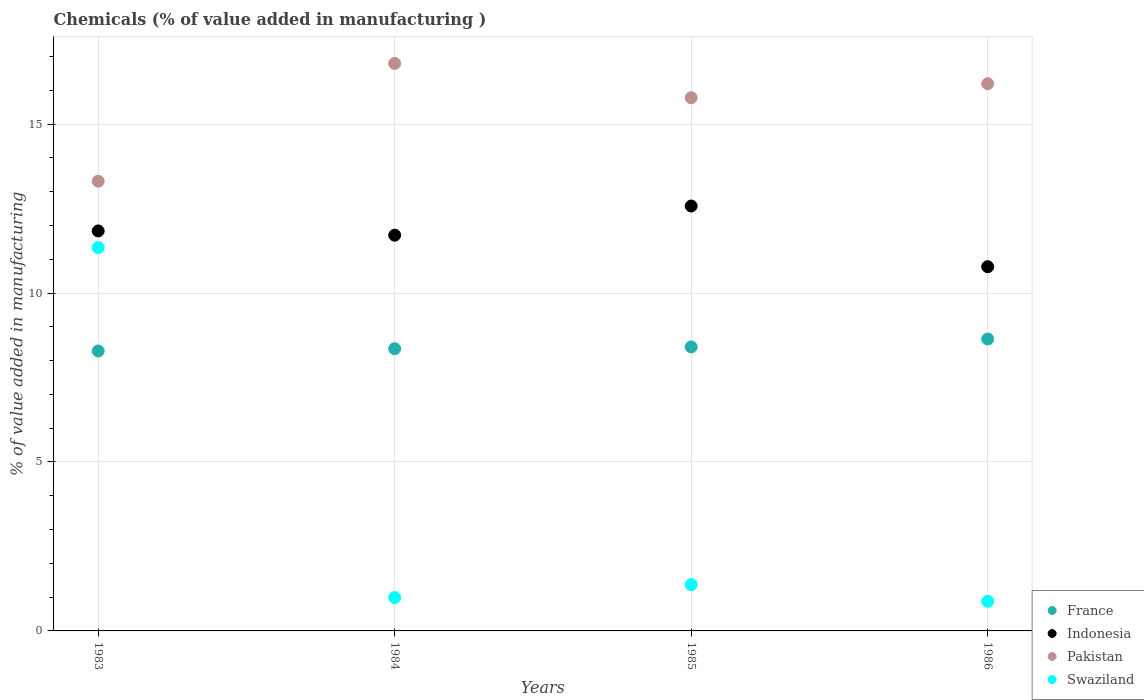How many different coloured dotlines are there?
Your answer should be very brief. 4. Is the number of dotlines equal to the number of legend labels?
Make the answer very short. Yes. What is the value added in manufacturing chemicals in Pakistan in 1984?
Your answer should be compact. 16.79. Across all years, what is the maximum value added in manufacturing chemicals in Swaziland?
Your answer should be compact. 11.35. Across all years, what is the minimum value added in manufacturing chemicals in Pakistan?
Offer a very short reply. 13.31. In which year was the value added in manufacturing chemicals in Pakistan minimum?
Give a very brief answer. 1983. What is the total value added in manufacturing chemicals in France in the graph?
Ensure brevity in your answer.  33.68. What is the difference between the value added in manufacturing chemicals in Indonesia in 1983 and that in 1985?
Your answer should be compact. -0.74. What is the difference between the value added in manufacturing chemicals in Pakistan in 1983 and the value added in manufacturing chemicals in France in 1986?
Offer a terse response. 4.67. What is the average value added in manufacturing chemicals in Swaziland per year?
Your response must be concise. 3.64. In the year 1983, what is the difference between the value added in manufacturing chemicals in Pakistan and value added in manufacturing chemicals in Indonesia?
Your answer should be compact. 1.47. In how many years, is the value added in manufacturing chemicals in Swaziland greater than 13 %?
Give a very brief answer. 0. What is the ratio of the value added in manufacturing chemicals in France in 1984 to that in 1986?
Provide a succinct answer. 0.97. Is the difference between the value added in manufacturing chemicals in Pakistan in 1983 and 1986 greater than the difference between the value added in manufacturing chemicals in Indonesia in 1983 and 1986?
Your answer should be very brief. No. What is the difference between the highest and the second highest value added in manufacturing chemicals in Indonesia?
Keep it short and to the point. 0.74. What is the difference between the highest and the lowest value added in manufacturing chemicals in Swaziland?
Make the answer very short. 10.47. In how many years, is the value added in manufacturing chemicals in Swaziland greater than the average value added in manufacturing chemicals in Swaziland taken over all years?
Ensure brevity in your answer.  1. Is the sum of the value added in manufacturing chemicals in France in 1983 and 1985 greater than the maximum value added in manufacturing chemicals in Swaziland across all years?
Give a very brief answer. Yes. How many years are there in the graph?
Provide a succinct answer. 4. What is the difference between two consecutive major ticks on the Y-axis?
Offer a very short reply. 5. Does the graph contain any zero values?
Your answer should be compact. No. Does the graph contain grids?
Provide a short and direct response. Yes. What is the title of the graph?
Provide a short and direct response. Chemicals (% of value added in manufacturing ). What is the label or title of the Y-axis?
Offer a very short reply. % of value added in manufacturing. What is the % of value added in manufacturing of France in 1983?
Your answer should be very brief. 8.28. What is the % of value added in manufacturing of Indonesia in 1983?
Offer a very short reply. 11.84. What is the % of value added in manufacturing of Pakistan in 1983?
Keep it short and to the point. 13.31. What is the % of value added in manufacturing in Swaziland in 1983?
Give a very brief answer. 11.35. What is the % of value added in manufacturing in France in 1984?
Provide a short and direct response. 8.35. What is the % of value added in manufacturing in Indonesia in 1984?
Give a very brief answer. 11.71. What is the % of value added in manufacturing of Pakistan in 1984?
Keep it short and to the point. 16.79. What is the % of value added in manufacturing in Swaziland in 1984?
Make the answer very short. 0.99. What is the % of value added in manufacturing in France in 1985?
Make the answer very short. 8.41. What is the % of value added in manufacturing in Indonesia in 1985?
Offer a terse response. 12.58. What is the % of value added in manufacturing in Pakistan in 1985?
Offer a very short reply. 15.78. What is the % of value added in manufacturing of Swaziland in 1985?
Your answer should be compact. 1.37. What is the % of value added in manufacturing in France in 1986?
Give a very brief answer. 8.64. What is the % of value added in manufacturing of Indonesia in 1986?
Offer a terse response. 10.78. What is the % of value added in manufacturing in Pakistan in 1986?
Your answer should be very brief. 16.2. What is the % of value added in manufacturing of Swaziland in 1986?
Keep it short and to the point. 0.88. Across all years, what is the maximum % of value added in manufacturing in France?
Offer a very short reply. 8.64. Across all years, what is the maximum % of value added in manufacturing of Indonesia?
Your answer should be very brief. 12.58. Across all years, what is the maximum % of value added in manufacturing of Pakistan?
Give a very brief answer. 16.79. Across all years, what is the maximum % of value added in manufacturing of Swaziland?
Keep it short and to the point. 11.35. Across all years, what is the minimum % of value added in manufacturing of France?
Ensure brevity in your answer.  8.28. Across all years, what is the minimum % of value added in manufacturing of Indonesia?
Provide a short and direct response. 10.78. Across all years, what is the minimum % of value added in manufacturing in Pakistan?
Your answer should be compact. 13.31. Across all years, what is the minimum % of value added in manufacturing of Swaziland?
Ensure brevity in your answer.  0.88. What is the total % of value added in manufacturing in France in the graph?
Provide a succinct answer. 33.68. What is the total % of value added in manufacturing in Indonesia in the graph?
Your response must be concise. 46.9. What is the total % of value added in manufacturing in Pakistan in the graph?
Make the answer very short. 62.08. What is the total % of value added in manufacturing in Swaziland in the graph?
Provide a succinct answer. 14.58. What is the difference between the % of value added in manufacturing in France in 1983 and that in 1984?
Ensure brevity in your answer.  -0.07. What is the difference between the % of value added in manufacturing of Indonesia in 1983 and that in 1984?
Give a very brief answer. 0.13. What is the difference between the % of value added in manufacturing in Pakistan in 1983 and that in 1984?
Your response must be concise. -3.48. What is the difference between the % of value added in manufacturing of Swaziland in 1983 and that in 1984?
Keep it short and to the point. 10.36. What is the difference between the % of value added in manufacturing of France in 1983 and that in 1985?
Your response must be concise. -0.12. What is the difference between the % of value added in manufacturing in Indonesia in 1983 and that in 1985?
Provide a succinct answer. -0.74. What is the difference between the % of value added in manufacturing of Pakistan in 1983 and that in 1985?
Your response must be concise. -2.47. What is the difference between the % of value added in manufacturing of Swaziland in 1983 and that in 1985?
Keep it short and to the point. 9.98. What is the difference between the % of value added in manufacturing of France in 1983 and that in 1986?
Keep it short and to the point. -0.35. What is the difference between the % of value added in manufacturing of Indonesia in 1983 and that in 1986?
Make the answer very short. 1.06. What is the difference between the % of value added in manufacturing in Pakistan in 1983 and that in 1986?
Provide a short and direct response. -2.88. What is the difference between the % of value added in manufacturing of Swaziland in 1983 and that in 1986?
Ensure brevity in your answer.  10.47. What is the difference between the % of value added in manufacturing of France in 1984 and that in 1985?
Provide a succinct answer. -0.05. What is the difference between the % of value added in manufacturing of Indonesia in 1984 and that in 1985?
Your response must be concise. -0.86. What is the difference between the % of value added in manufacturing in Pakistan in 1984 and that in 1985?
Provide a succinct answer. 1.01. What is the difference between the % of value added in manufacturing in Swaziland in 1984 and that in 1985?
Give a very brief answer. -0.38. What is the difference between the % of value added in manufacturing of France in 1984 and that in 1986?
Offer a very short reply. -0.29. What is the difference between the % of value added in manufacturing of Indonesia in 1984 and that in 1986?
Your response must be concise. 0.93. What is the difference between the % of value added in manufacturing of Pakistan in 1984 and that in 1986?
Ensure brevity in your answer.  0.6. What is the difference between the % of value added in manufacturing of Swaziland in 1984 and that in 1986?
Ensure brevity in your answer.  0.11. What is the difference between the % of value added in manufacturing of France in 1985 and that in 1986?
Provide a succinct answer. -0.23. What is the difference between the % of value added in manufacturing of Indonesia in 1985 and that in 1986?
Make the answer very short. 1.8. What is the difference between the % of value added in manufacturing of Pakistan in 1985 and that in 1986?
Ensure brevity in your answer.  -0.41. What is the difference between the % of value added in manufacturing in Swaziland in 1985 and that in 1986?
Your answer should be very brief. 0.49. What is the difference between the % of value added in manufacturing in France in 1983 and the % of value added in manufacturing in Indonesia in 1984?
Keep it short and to the point. -3.43. What is the difference between the % of value added in manufacturing in France in 1983 and the % of value added in manufacturing in Pakistan in 1984?
Keep it short and to the point. -8.51. What is the difference between the % of value added in manufacturing of France in 1983 and the % of value added in manufacturing of Swaziland in 1984?
Offer a very short reply. 7.3. What is the difference between the % of value added in manufacturing in Indonesia in 1983 and the % of value added in manufacturing in Pakistan in 1984?
Ensure brevity in your answer.  -4.96. What is the difference between the % of value added in manufacturing of Indonesia in 1983 and the % of value added in manufacturing of Swaziland in 1984?
Provide a succinct answer. 10.85. What is the difference between the % of value added in manufacturing in Pakistan in 1983 and the % of value added in manufacturing in Swaziland in 1984?
Your answer should be compact. 12.32. What is the difference between the % of value added in manufacturing in France in 1983 and the % of value added in manufacturing in Indonesia in 1985?
Ensure brevity in your answer.  -4.29. What is the difference between the % of value added in manufacturing in France in 1983 and the % of value added in manufacturing in Pakistan in 1985?
Keep it short and to the point. -7.5. What is the difference between the % of value added in manufacturing in France in 1983 and the % of value added in manufacturing in Swaziland in 1985?
Ensure brevity in your answer.  6.92. What is the difference between the % of value added in manufacturing in Indonesia in 1983 and the % of value added in manufacturing in Pakistan in 1985?
Your response must be concise. -3.94. What is the difference between the % of value added in manufacturing in Indonesia in 1983 and the % of value added in manufacturing in Swaziland in 1985?
Provide a succinct answer. 10.47. What is the difference between the % of value added in manufacturing of Pakistan in 1983 and the % of value added in manufacturing of Swaziland in 1985?
Give a very brief answer. 11.94. What is the difference between the % of value added in manufacturing in France in 1983 and the % of value added in manufacturing in Indonesia in 1986?
Offer a very short reply. -2.49. What is the difference between the % of value added in manufacturing of France in 1983 and the % of value added in manufacturing of Pakistan in 1986?
Ensure brevity in your answer.  -7.91. What is the difference between the % of value added in manufacturing in France in 1983 and the % of value added in manufacturing in Swaziland in 1986?
Make the answer very short. 7.41. What is the difference between the % of value added in manufacturing of Indonesia in 1983 and the % of value added in manufacturing of Pakistan in 1986?
Provide a short and direct response. -4.36. What is the difference between the % of value added in manufacturing in Indonesia in 1983 and the % of value added in manufacturing in Swaziland in 1986?
Offer a very short reply. 10.96. What is the difference between the % of value added in manufacturing of Pakistan in 1983 and the % of value added in manufacturing of Swaziland in 1986?
Keep it short and to the point. 12.43. What is the difference between the % of value added in manufacturing in France in 1984 and the % of value added in manufacturing in Indonesia in 1985?
Offer a very short reply. -4.22. What is the difference between the % of value added in manufacturing of France in 1984 and the % of value added in manufacturing of Pakistan in 1985?
Your answer should be very brief. -7.43. What is the difference between the % of value added in manufacturing in France in 1984 and the % of value added in manufacturing in Swaziland in 1985?
Offer a terse response. 6.98. What is the difference between the % of value added in manufacturing of Indonesia in 1984 and the % of value added in manufacturing of Pakistan in 1985?
Ensure brevity in your answer.  -4.07. What is the difference between the % of value added in manufacturing of Indonesia in 1984 and the % of value added in manufacturing of Swaziland in 1985?
Your response must be concise. 10.34. What is the difference between the % of value added in manufacturing of Pakistan in 1984 and the % of value added in manufacturing of Swaziland in 1985?
Provide a succinct answer. 15.43. What is the difference between the % of value added in manufacturing in France in 1984 and the % of value added in manufacturing in Indonesia in 1986?
Provide a succinct answer. -2.43. What is the difference between the % of value added in manufacturing in France in 1984 and the % of value added in manufacturing in Pakistan in 1986?
Keep it short and to the point. -7.84. What is the difference between the % of value added in manufacturing of France in 1984 and the % of value added in manufacturing of Swaziland in 1986?
Your answer should be very brief. 7.48. What is the difference between the % of value added in manufacturing in Indonesia in 1984 and the % of value added in manufacturing in Pakistan in 1986?
Your response must be concise. -4.48. What is the difference between the % of value added in manufacturing in Indonesia in 1984 and the % of value added in manufacturing in Swaziland in 1986?
Offer a terse response. 10.83. What is the difference between the % of value added in manufacturing in Pakistan in 1984 and the % of value added in manufacturing in Swaziland in 1986?
Your response must be concise. 15.92. What is the difference between the % of value added in manufacturing in France in 1985 and the % of value added in manufacturing in Indonesia in 1986?
Ensure brevity in your answer.  -2.37. What is the difference between the % of value added in manufacturing of France in 1985 and the % of value added in manufacturing of Pakistan in 1986?
Give a very brief answer. -7.79. What is the difference between the % of value added in manufacturing in France in 1985 and the % of value added in manufacturing in Swaziland in 1986?
Offer a terse response. 7.53. What is the difference between the % of value added in manufacturing of Indonesia in 1985 and the % of value added in manufacturing of Pakistan in 1986?
Ensure brevity in your answer.  -3.62. What is the difference between the % of value added in manufacturing of Indonesia in 1985 and the % of value added in manufacturing of Swaziland in 1986?
Your answer should be compact. 11.7. What is the difference between the % of value added in manufacturing in Pakistan in 1985 and the % of value added in manufacturing in Swaziland in 1986?
Your answer should be very brief. 14.9. What is the average % of value added in manufacturing of France per year?
Make the answer very short. 8.42. What is the average % of value added in manufacturing in Indonesia per year?
Provide a short and direct response. 11.73. What is the average % of value added in manufacturing in Pakistan per year?
Your answer should be compact. 15.52. What is the average % of value added in manufacturing in Swaziland per year?
Your answer should be compact. 3.64. In the year 1983, what is the difference between the % of value added in manufacturing of France and % of value added in manufacturing of Indonesia?
Your response must be concise. -3.55. In the year 1983, what is the difference between the % of value added in manufacturing in France and % of value added in manufacturing in Pakistan?
Ensure brevity in your answer.  -5.03. In the year 1983, what is the difference between the % of value added in manufacturing of France and % of value added in manufacturing of Swaziland?
Give a very brief answer. -3.06. In the year 1983, what is the difference between the % of value added in manufacturing in Indonesia and % of value added in manufacturing in Pakistan?
Provide a short and direct response. -1.47. In the year 1983, what is the difference between the % of value added in manufacturing of Indonesia and % of value added in manufacturing of Swaziland?
Offer a terse response. 0.49. In the year 1983, what is the difference between the % of value added in manufacturing of Pakistan and % of value added in manufacturing of Swaziland?
Make the answer very short. 1.96. In the year 1984, what is the difference between the % of value added in manufacturing in France and % of value added in manufacturing in Indonesia?
Keep it short and to the point. -3.36. In the year 1984, what is the difference between the % of value added in manufacturing of France and % of value added in manufacturing of Pakistan?
Offer a terse response. -8.44. In the year 1984, what is the difference between the % of value added in manufacturing of France and % of value added in manufacturing of Swaziland?
Offer a very short reply. 7.37. In the year 1984, what is the difference between the % of value added in manufacturing of Indonesia and % of value added in manufacturing of Pakistan?
Keep it short and to the point. -5.08. In the year 1984, what is the difference between the % of value added in manufacturing of Indonesia and % of value added in manufacturing of Swaziland?
Your answer should be compact. 10.73. In the year 1984, what is the difference between the % of value added in manufacturing of Pakistan and % of value added in manufacturing of Swaziland?
Ensure brevity in your answer.  15.81. In the year 1985, what is the difference between the % of value added in manufacturing of France and % of value added in manufacturing of Indonesia?
Give a very brief answer. -4.17. In the year 1985, what is the difference between the % of value added in manufacturing of France and % of value added in manufacturing of Pakistan?
Provide a succinct answer. -7.38. In the year 1985, what is the difference between the % of value added in manufacturing of France and % of value added in manufacturing of Swaziland?
Your response must be concise. 7.04. In the year 1985, what is the difference between the % of value added in manufacturing in Indonesia and % of value added in manufacturing in Pakistan?
Make the answer very short. -3.2. In the year 1985, what is the difference between the % of value added in manufacturing of Indonesia and % of value added in manufacturing of Swaziland?
Keep it short and to the point. 11.21. In the year 1985, what is the difference between the % of value added in manufacturing in Pakistan and % of value added in manufacturing in Swaziland?
Provide a succinct answer. 14.41. In the year 1986, what is the difference between the % of value added in manufacturing in France and % of value added in manufacturing in Indonesia?
Your response must be concise. -2.14. In the year 1986, what is the difference between the % of value added in manufacturing of France and % of value added in manufacturing of Pakistan?
Ensure brevity in your answer.  -7.56. In the year 1986, what is the difference between the % of value added in manufacturing in France and % of value added in manufacturing in Swaziland?
Offer a very short reply. 7.76. In the year 1986, what is the difference between the % of value added in manufacturing in Indonesia and % of value added in manufacturing in Pakistan?
Give a very brief answer. -5.42. In the year 1986, what is the difference between the % of value added in manufacturing in Indonesia and % of value added in manufacturing in Swaziland?
Keep it short and to the point. 9.9. In the year 1986, what is the difference between the % of value added in manufacturing of Pakistan and % of value added in manufacturing of Swaziland?
Provide a short and direct response. 15.32. What is the ratio of the % of value added in manufacturing of Indonesia in 1983 to that in 1984?
Make the answer very short. 1.01. What is the ratio of the % of value added in manufacturing of Pakistan in 1983 to that in 1984?
Make the answer very short. 0.79. What is the ratio of the % of value added in manufacturing of Swaziland in 1983 to that in 1984?
Your answer should be compact. 11.5. What is the ratio of the % of value added in manufacturing in France in 1983 to that in 1985?
Provide a succinct answer. 0.99. What is the ratio of the % of value added in manufacturing of Indonesia in 1983 to that in 1985?
Provide a succinct answer. 0.94. What is the ratio of the % of value added in manufacturing in Pakistan in 1983 to that in 1985?
Offer a terse response. 0.84. What is the ratio of the % of value added in manufacturing of Swaziland in 1983 to that in 1985?
Provide a succinct answer. 8.29. What is the ratio of the % of value added in manufacturing in France in 1983 to that in 1986?
Your answer should be compact. 0.96. What is the ratio of the % of value added in manufacturing in Indonesia in 1983 to that in 1986?
Make the answer very short. 1.1. What is the ratio of the % of value added in manufacturing of Pakistan in 1983 to that in 1986?
Give a very brief answer. 0.82. What is the ratio of the % of value added in manufacturing of Swaziland in 1983 to that in 1986?
Ensure brevity in your answer.  12.93. What is the ratio of the % of value added in manufacturing in France in 1984 to that in 1985?
Provide a succinct answer. 0.99. What is the ratio of the % of value added in manufacturing of Indonesia in 1984 to that in 1985?
Give a very brief answer. 0.93. What is the ratio of the % of value added in manufacturing of Pakistan in 1984 to that in 1985?
Your answer should be compact. 1.06. What is the ratio of the % of value added in manufacturing of Swaziland in 1984 to that in 1985?
Give a very brief answer. 0.72. What is the ratio of the % of value added in manufacturing in France in 1984 to that in 1986?
Offer a very short reply. 0.97. What is the ratio of the % of value added in manufacturing of Indonesia in 1984 to that in 1986?
Offer a very short reply. 1.09. What is the ratio of the % of value added in manufacturing in Swaziland in 1984 to that in 1986?
Your response must be concise. 1.12. What is the ratio of the % of value added in manufacturing of France in 1985 to that in 1986?
Ensure brevity in your answer.  0.97. What is the ratio of the % of value added in manufacturing in Pakistan in 1985 to that in 1986?
Give a very brief answer. 0.97. What is the ratio of the % of value added in manufacturing in Swaziland in 1985 to that in 1986?
Your answer should be very brief. 1.56. What is the difference between the highest and the second highest % of value added in manufacturing in France?
Provide a short and direct response. 0.23. What is the difference between the highest and the second highest % of value added in manufacturing in Indonesia?
Keep it short and to the point. 0.74. What is the difference between the highest and the second highest % of value added in manufacturing of Pakistan?
Ensure brevity in your answer.  0.6. What is the difference between the highest and the second highest % of value added in manufacturing of Swaziland?
Offer a very short reply. 9.98. What is the difference between the highest and the lowest % of value added in manufacturing in France?
Offer a terse response. 0.35. What is the difference between the highest and the lowest % of value added in manufacturing in Indonesia?
Offer a very short reply. 1.8. What is the difference between the highest and the lowest % of value added in manufacturing of Pakistan?
Ensure brevity in your answer.  3.48. What is the difference between the highest and the lowest % of value added in manufacturing of Swaziland?
Your response must be concise. 10.47. 